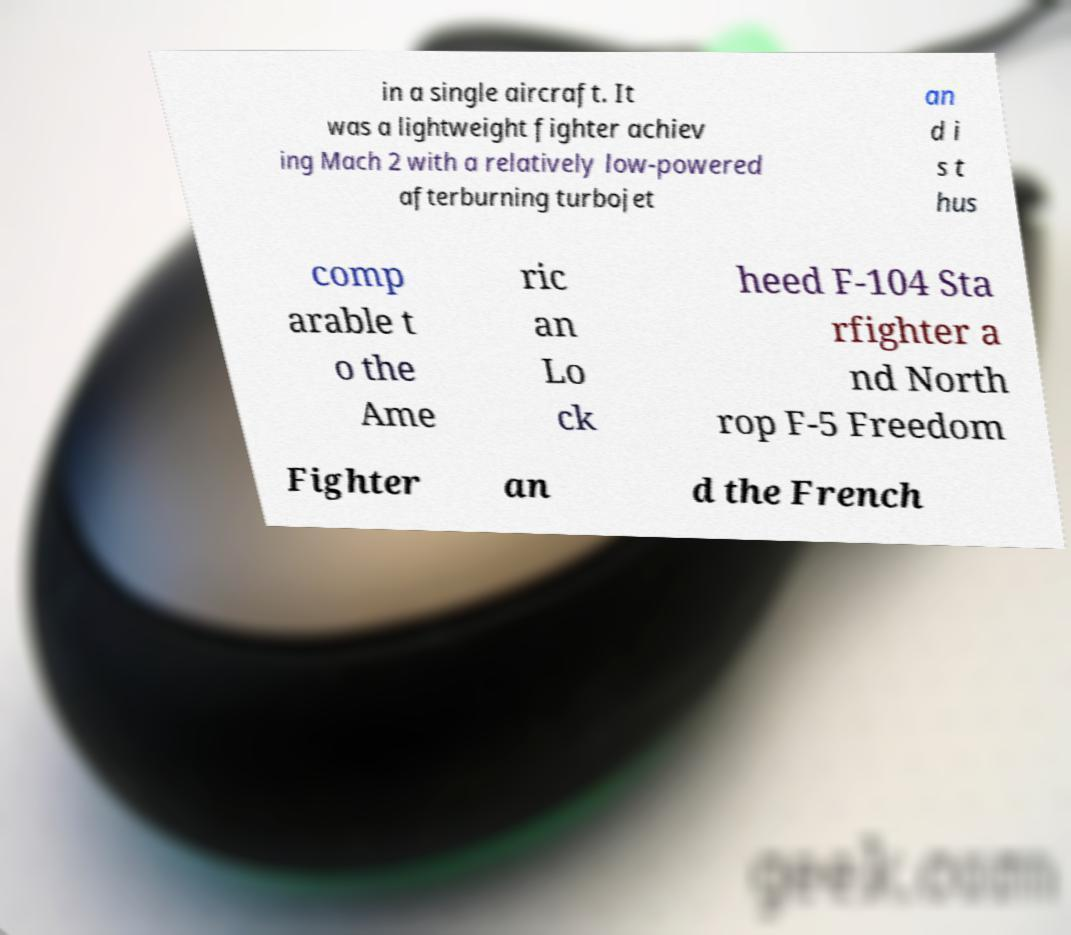Please read and relay the text visible in this image. What does it say? in a single aircraft. It was a lightweight fighter achiev ing Mach 2 with a relatively low-powered afterburning turbojet an d i s t hus comp arable t o the Ame ric an Lo ck heed F-104 Sta rfighter a nd North rop F-5 Freedom Fighter an d the French 